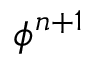Convert formula to latex. <formula><loc_0><loc_0><loc_500><loc_500>\phi ^ { n + 1 }</formula> 